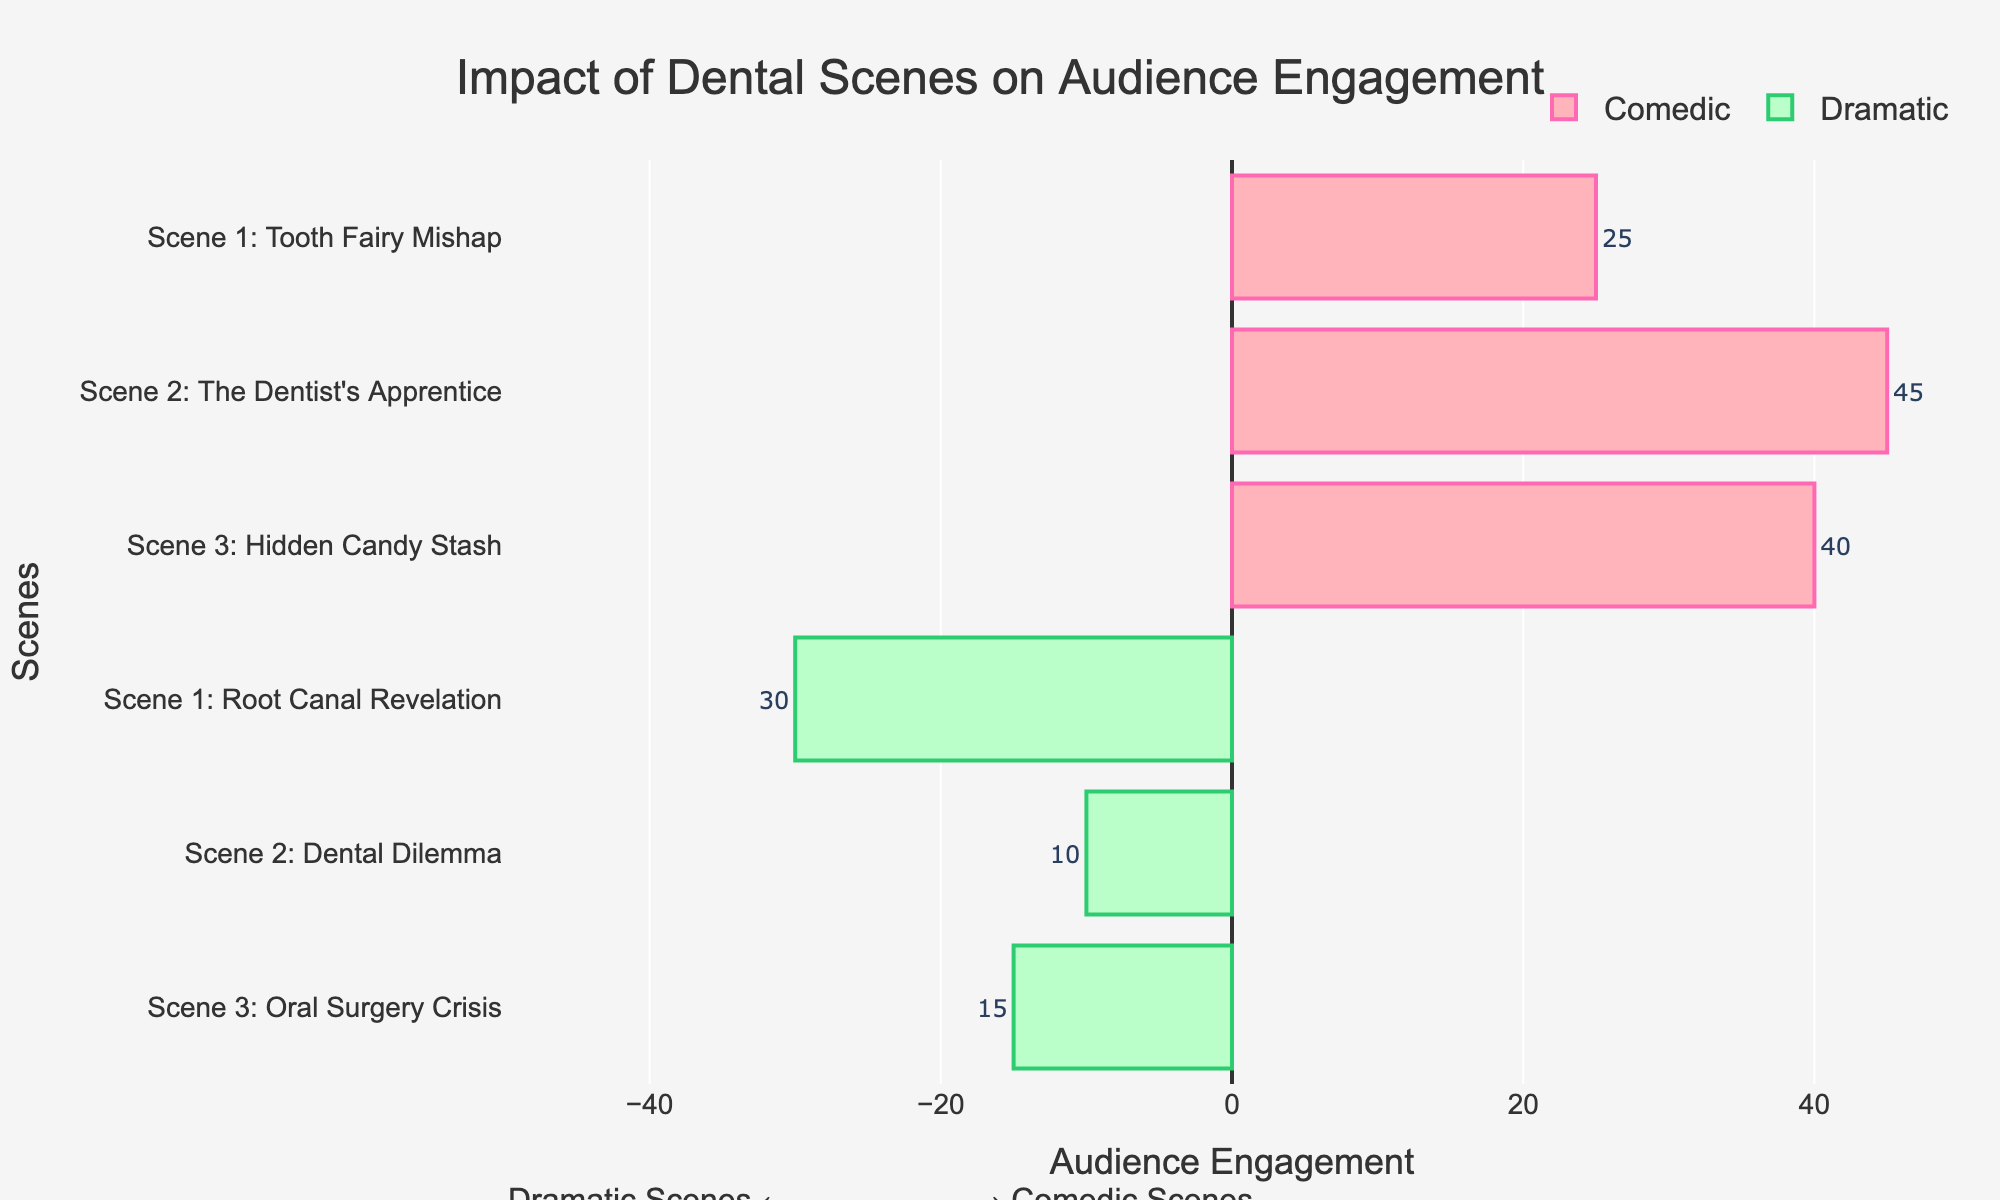Which type of scene has the highest audience engagement? By examining the bar lengths and labels, "The Dentist's Apprentice" under the Comedic category has the highest audience engagement with a value of 45.
Answer: Comedic What's the total audience engagement for all the Comedic scenes combined? Summing audience engagements for Comedic scenes: 25 (Scene 1) + 45 (Scene 2) + 40 (Scene 3) = 110.
Answer: 110 How much more engaging is "The Dentist's Apprentice" compared to "Oral Surgery Crisis"? "The Dentist's Apprentice" has 45, and "Oral Surgery Crisis" has 15. The difference is 45 - 15 = 30.
Answer: 30 Which scene has the least audience engagement? The shortest bar for the scene labeled with the smallest value is "Dental Dilemma" with an engagement of 10.
Answer: Dental Dilemma What is the average audience engagement for Dramatic scenes? Sum the engagements for Dramatic scenes: 30 (Scene 1) + 10 (Scene 2) + 15 (Scene 3) = 55. Then divide by the number of scenes: 55 / 3 ≈ 18.33.
Answer: 18.33 Are any of the Dramatic scenes more engaging than the least engaging Comedic scene? The least engaging Comedic scene is "Tooth Fairy Mishap" with an engagement of 25. None of the Dramatic scenes exceed 25, with the highest being "Root Canal Revelation" with an engagement of 30.
Answer: No Which scene is more engaging, "Tooth Fairy Mishap" or "Root Canal Revelation"? Compare their audience engagements: "Tooth Fairy Mishap" has 25, and "Root Canal Revelation" has 30.
Answer: Root Canal Revelation What is the range of audience engagement values for Comedic scenes? The highest engagement is 45 ("The Dentist's Apprentice") and the lowest is 25 ("Tooth Fairy Mishap"). The range is 45 - 25 = 20.
Answer: 20 